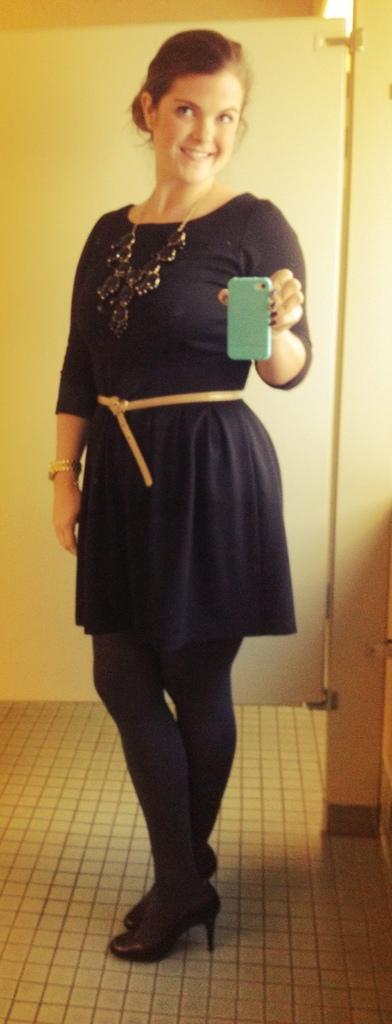Could you give a brief overview of what you see in this image? In this picture we can see a woman standing on the floor and she is holding a mobile and in the background we can see the door. 